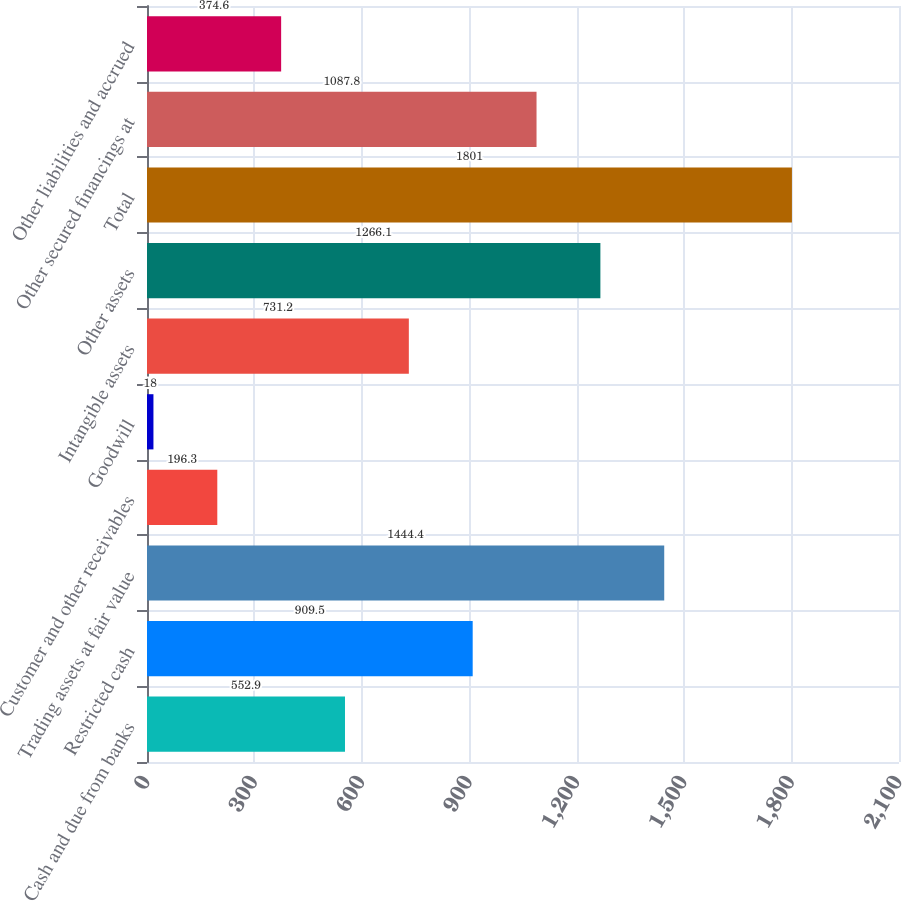Convert chart. <chart><loc_0><loc_0><loc_500><loc_500><bar_chart><fcel>Cash and due from banks<fcel>Restricted cash<fcel>Trading assets at fair value<fcel>Customer and other receivables<fcel>Goodwill<fcel>Intangible assets<fcel>Other assets<fcel>Total<fcel>Other secured financings at<fcel>Other liabilities and accrued<nl><fcel>552.9<fcel>909.5<fcel>1444.4<fcel>196.3<fcel>18<fcel>731.2<fcel>1266.1<fcel>1801<fcel>1087.8<fcel>374.6<nl></chart> 